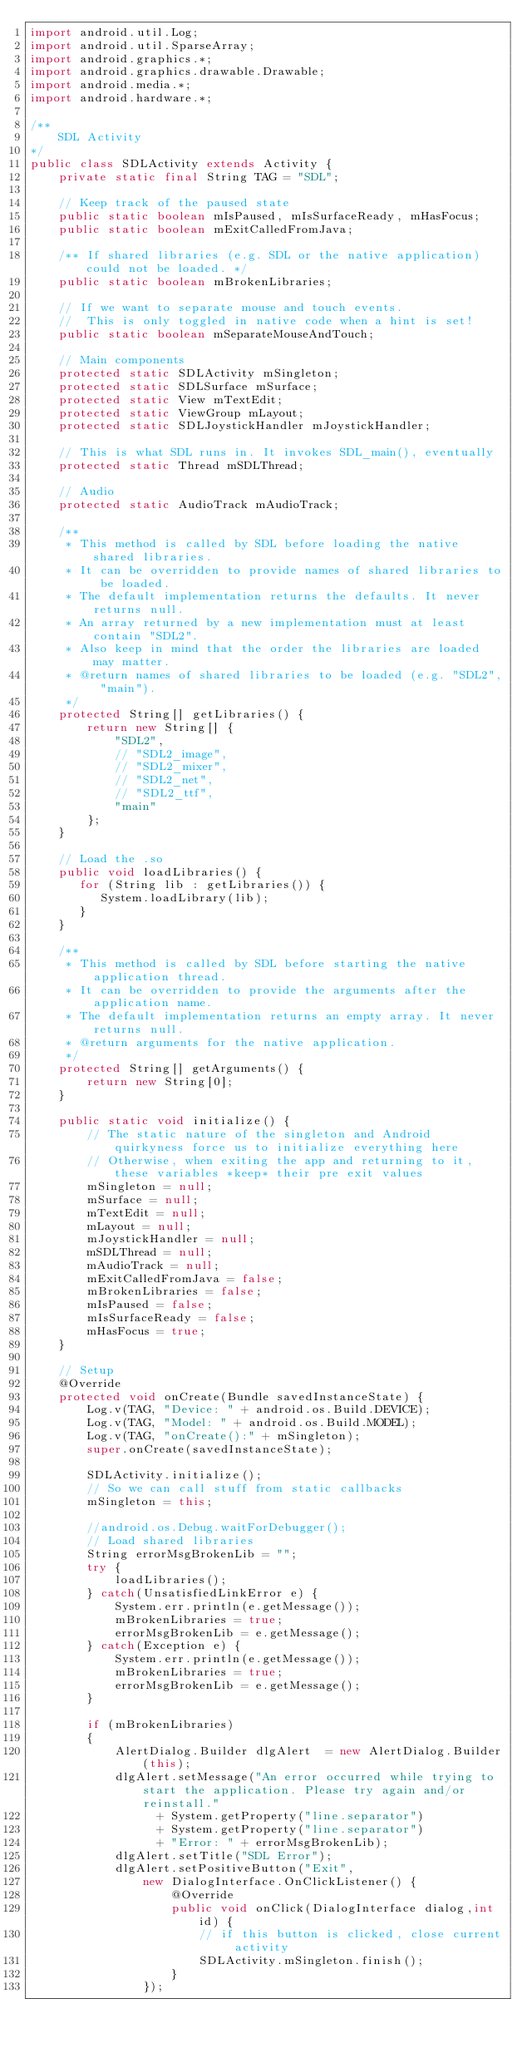<code> <loc_0><loc_0><loc_500><loc_500><_Java_>import android.util.Log;
import android.util.SparseArray;
import android.graphics.*;
import android.graphics.drawable.Drawable;
import android.media.*;
import android.hardware.*;

/**
    SDL Activity
*/
public class SDLActivity extends Activity {
    private static final String TAG = "SDL";

    // Keep track of the paused state
    public static boolean mIsPaused, mIsSurfaceReady, mHasFocus;
    public static boolean mExitCalledFromJava;

    /** If shared libraries (e.g. SDL or the native application) could not be loaded. */
    public static boolean mBrokenLibraries;

    // If we want to separate mouse and touch events.
    //  This is only toggled in native code when a hint is set!
    public static boolean mSeparateMouseAndTouch;

    // Main components
    protected static SDLActivity mSingleton;
    protected static SDLSurface mSurface;
    protected static View mTextEdit;
    protected static ViewGroup mLayout;
    protected static SDLJoystickHandler mJoystickHandler;

    // This is what SDL runs in. It invokes SDL_main(), eventually
    protected static Thread mSDLThread;

    // Audio
    protected static AudioTrack mAudioTrack;

    /**
     * This method is called by SDL before loading the native shared libraries.
     * It can be overridden to provide names of shared libraries to be loaded.
     * The default implementation returns the defaults. It never returns null.
     * An array returned by a new implementation must at least contain "SDL2".
     * Also keep in mind that the order the libraries are loaded may matter.
     * @return names of shared libraries to be loaded (e.g. "SDL2", "main").
     */
    protected String[] getLibraries() {
        return new String[] {
            "SDL2",
            // "SDL2_image",
            // "SDL2_mixer",
            // "SDL2_net",
            // "SDL2_ttf",
            "main"
        };
    }

    // Load the .so
    public void loadLibraries() {
       for (String lib : getLibraries()) {
          System.loadLibrary(lib);
       }
    }

    /**
     * This method is called by SDL before starting the native application thread.
     * It can be overridden to provide the arguments after the application name.
     * The default implementation returns an empty array. It never returns null.
     * @return arguments for the native application.
     */
    protected String[] getArguments() {
        return new String[0];
    }

    public static void initialize() {
        // The static nature of the singleton and Android quirkyness force us to initialize everything here
        // Otherwise, when exiting the app and returning to it, these variables *keep* their pre exit values
        mSingleton = null;
        mSurface = null;
        mTextEdit = null;
        mLayout = null;
        mJoystickHandler = null;
        mSDLThread = null;
        mAudioTrack = null;
        mExitCalledFromJava = false;
        mBrokenLibraries = false;
        mIsPaused = false;
        mIsSurfaceReady = false;
        mHasFocus = true;
    }

    // Setup
    @Override
    protected void onCreate(Bundle savedInstanceState) {
        Log.v(TAG, "Device: " + android.os.Build.DEVICE);
        Log.v(TAG, "Model: " + android.os.Build.MODEL);
        Log.v(TAG, "onCreate():" + mSingleton);
        super.onCreate(savedInstanceState);

        SDLActivity.initialize();
        // So we can call stuff from static callbacks
        mSingleton = this;

        //android.os.Debug.waitForDebugger();
        // Load shared libraries
        String errorMsgBrokenLib = "";
        try {
            loadLibraries();
        } catch(UnsatisfiedLinkError e) {
            System.err.println(e.getMessage());
            mBrokenLibraries = true;
            errorMsgBrokenLib = e.getMessage();
        } catch(Exception e) {
            System.err.println(e.getMessage());
            mBrokenLibraries = true;
            errorMsgBrokenLib = e.getMessage();
        }

        if (mBrokenLibraries)
        {
            AlertDialog.Builder dlgAlert  = new AlertDialog.Builder(this);
            dlgAlert.setMessage("An error occurred while trying to start the application. Please try again and/or reinstall."
                  + System.getProperty("line.separator")
                  + System.getProperty("line.separator")
                  + "Error: " + errorMsgBrokenLib);
            dlgAlert.setTitle("SDL Error");
            dlgAlert.setPositiveButton("Exit",
                new DialogInterface.OnClickListener() {
                    @Override
                    public void onClick(DialogInterface dialog,int id) {
                        // if this button is clicked, close current activity
                        SDLActivity.mSingleton.finish();
                    }
                });</code> 